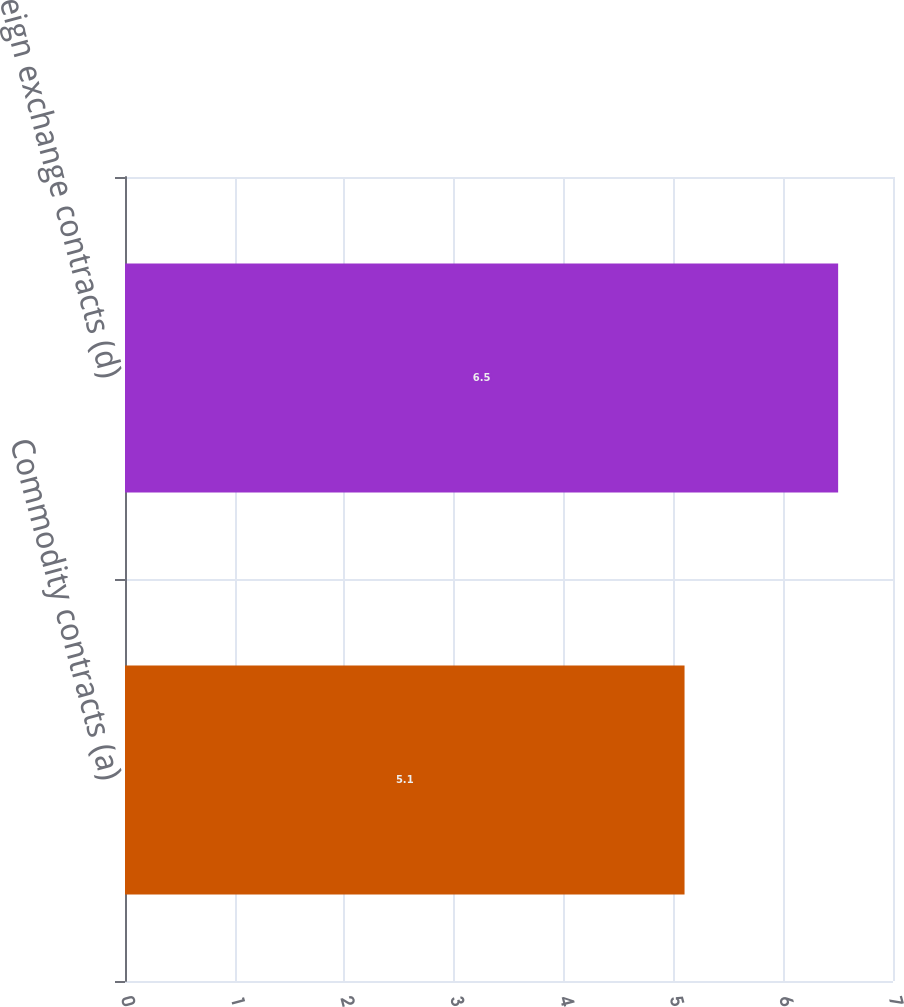Convert chart to OTSL. <chart><loc_0><loc_0><loc_500><loc_500><bar_chart><fcel>Commodity contracts (a)<fcel>Foreign exchange contracts (d)<nl><fcel>5.1<fcel>6.5<nl></chart> 